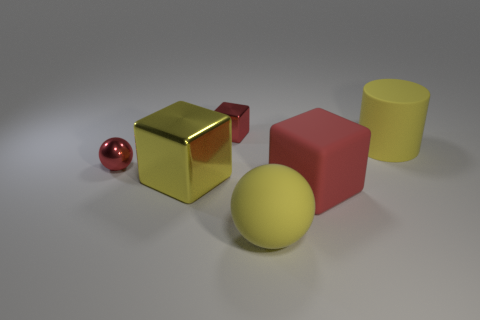Subtract all big metallic cubes. How many cubes are left? 2 Add 4 big green cubes. How many objects exist? 10 Subtract all red balls. Subtract all gray cylinders. How many balls are left? 1 Subtract all gray cylinders. How many red cubes are left? 2 Subtract all red spheres. Subtract all purple balls. How many objects are left? 5 Add 1 cylinders. How many cylinders are left? 2 Add 5 tiny cyan blocks. How many tiny cyan blocks exist? 5 Subtract all red blocks. How many blocks are left? 1 Subtract 1 yellow cubes. How many objects are left? 5 Subtract all spheres. How many objects are left? 4 